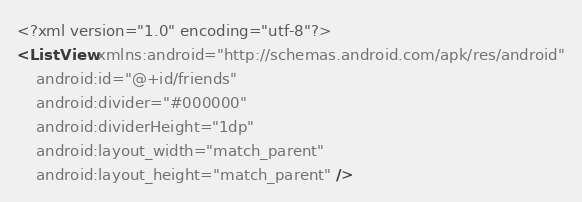<code> <loc_0><loc_0><loc_500><loc_500><_XML_><?xml version="1.0" encoding="utf-8"?>
<ListView xmlns:android="http://schemas.android.com/apk/res/android"
    android:id="@+id/friends"
    android:divider="#000000"
    android:dividerHeight="1dp"
    android:layout_width="match_parent"
    android:layout_height="match_parent" />
</code> 